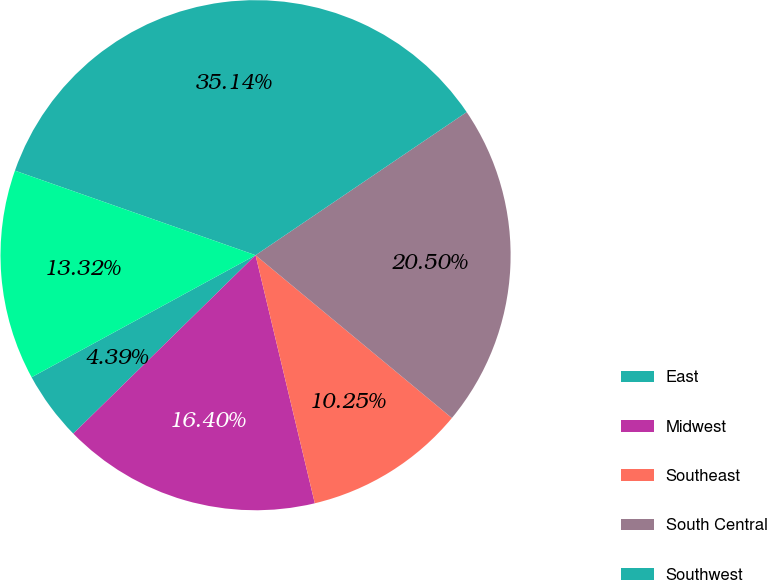Convert chart to OTSL. <chart><loc_0><loc_0><loc_500><loc_500><pie_chart><fcel>East<fcel>Midwest<fcel>Southeast<fcel>South Central<fcel>Southwest<fcel>West<nl><fcel>4.39%<fcel>16.4%<fcel>10.25%<fcel>20.5%<fcel>35.14%<fcel>13.32%<nl></chart> 